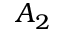Convert formula to latex. <formula><loc_0><loc_0><loc_500><loc_500>A _ { 2 }</formula> 